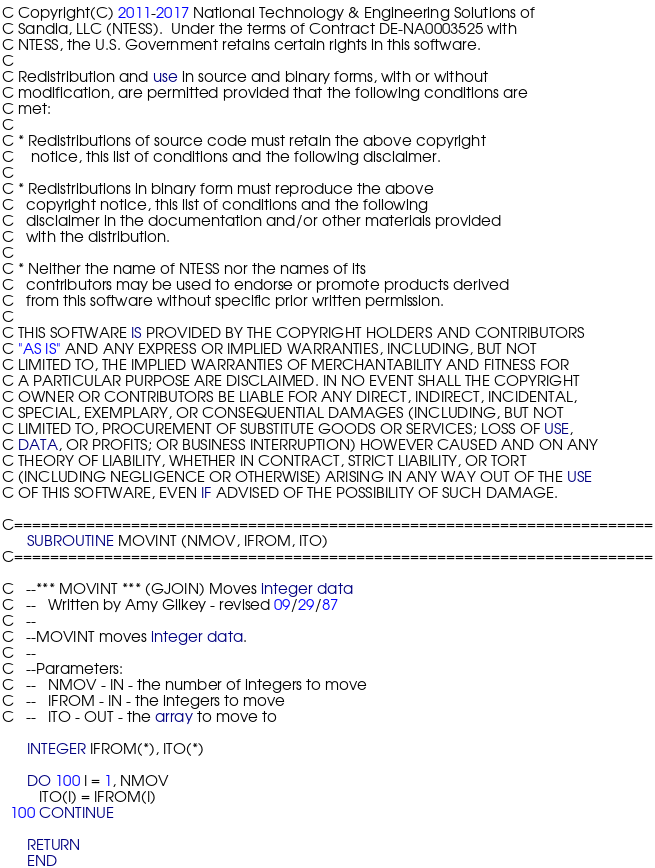<code> <loc_0><loc_0><loc_500><loc_500><_FORTRAN_>C Copyright(C) 2011-2017 National Technology & Engineering Solutions of
C Sandia, LLC (NTESS).  Under the terms of Contract DE-NA0003525 with
C NTESS, the U.S. Government retains certain rights in this software.
C
C Redistribution and use in source and binary forms, with or without
C modification, are permitted provided that the following conditions are
C met:
C
C * Redistributions of source code must retain the above copyright
C    notice, this list of conditions and the following disclaimer.
C
C * Redistributions in binary form must reproduce the above
C   copyright notice, this list of conditions and the following
C   disclaimer in the documentation and/or other materials provided
C   with the distribution.
C
C * Neither the name of NTESS nor the names of its
C   contributors may be used to endorse or promote products derived
C   from this software without specific prior written permission.
C
C THIS SOFTWARE IS PROVIDED BY THE COPYRIGHT HOLDERS AND CONTRIBUTORS
C "AS IS" AND ANY EXPRESS OR IMPLIED WARRANTIES, INCLUDING, BUT NOT
C LIMITED TO, THE IMPLIED WARRANTIES OF MERCHANTABILITY AND FITNESS FOR
C A PARTICULAR PURPOSE ARE DISCLAIMED. IN NO EVENT SHALL THE COPYRIGHT
C OWNER OR CONTRIBUTORS BE LIABLE FOR ANY DIRECT, INDIRECT, INCIDENTAL,
C SPECIAL, EXEMPLARY, OR CONSEQUENTIAL DAMAGES (INCLUDING, BUT NOT
C LIMITED TO, PROCUREMENT OF SUBSTITUTE GOODS OR SERVICES; LOSS OF USE,
C DATA, OR PROFITS; OR BUSINESS INTERRUPTION) HOWEVER CAUSED AND ON ANY
C THEORY OF LIABILITY, WHETHER IN CONTRACT, STRICT LIABILITY, OR TORT
C (INCLUDING NEGLIGENCE OR OTHERWISE) ARISING IN ANY WAY OUT OF THE USE
C OF THIS SOFTWARE, EVEN IF ADVISED OF THE POSSIBILITY OF SUCH DAMAGE.

C=======================================================================
      SUBROUTINE MOVINT (NMOV, IFROM, ITO)
C=======================================================================

C   --*** MOVINT *** (GJOIN) Moves integer data
C   --   Written by Amy Gilkey - revised 09/29/87
C   --
C   --MOVINT moves integer data.
C   --
C   --Parameters:
C   --   NMOV - IN - the number of integers to move
C   --   IFROM - IN - the integers to move
C   --   ITO - OUT - the array to move to

      INTEGER IFROM(*), ITO(*)

      DO 100 I = 1, NMOV
         ITO(I) = IFROM(I)
  100 CONTINUE

      RETURN
      END
</code> 